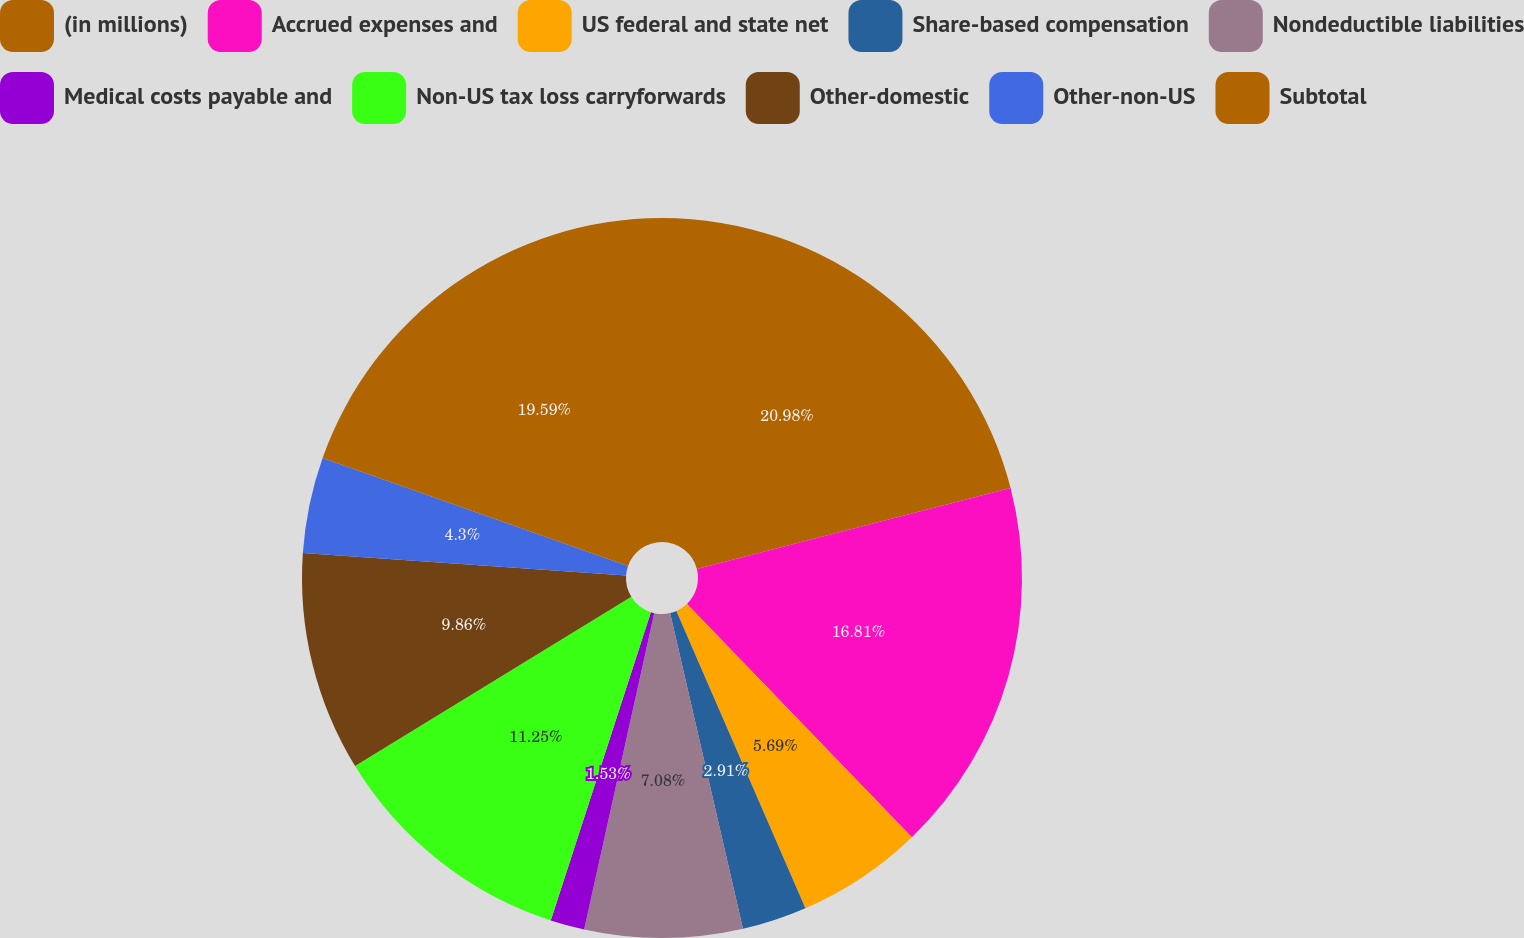Convert chart to OTSL. <chart><loc_0><loc_0><loc_500><loc_500><pie_chart><fcel>(in millions)<fcel>Accrued expenses and<fcel>US federal and state net<fcel>Share-based compensation<fcel>Nondeductible liabilities<fcel>Medical costs payable and<fcel>Non-US tax loss carryforwards<fcel>Other-domestic<fcel>Other-non-US<fcel>Subtotal<nl><fcel>20.98%<fcel>16.81%<fcel>5.69%<fcel>2.91%<fcel>7.08%<fcel>1.53%<fcel>11.25%<fcel>9.86%<fcel>4.3%<fcel>19.59%<nl></chart> 